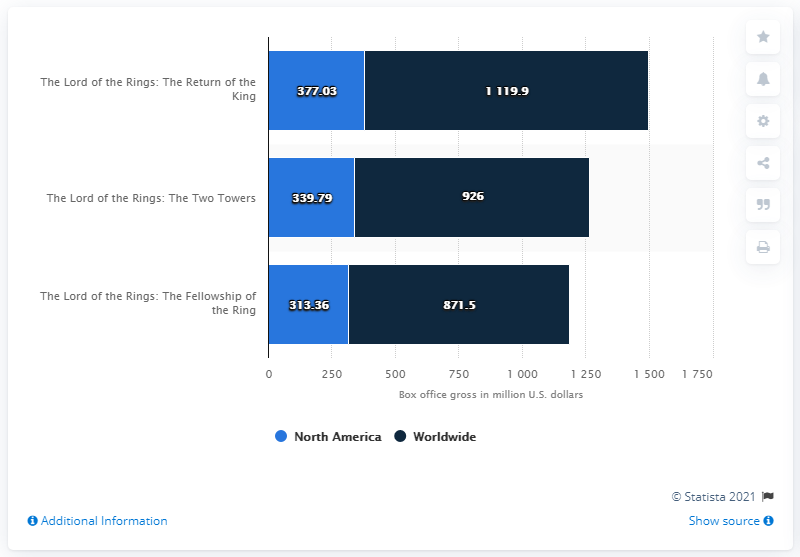Specify some key components in this picture. The result of adding the biggest dark blue bar to the smallest light blue bar is 1433.26. The average box office revenue of The Lord of the Rings Trilogy in North America was 343.39 million dollars. The gross of The Lord of the Rings: The Two Towers was 339.79 million dollars. 